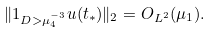Convert formula to latex. <formula><loc_0><loc_0><loc_500><loc_500>\| 1 _ { D > \mu _ { 4 } ^ { - 3 } } u ( t _ { * } ) \| _ { 2 } = O _ { L ^ { 2 } } ( \mu _ { 1 } ) .</formula> 